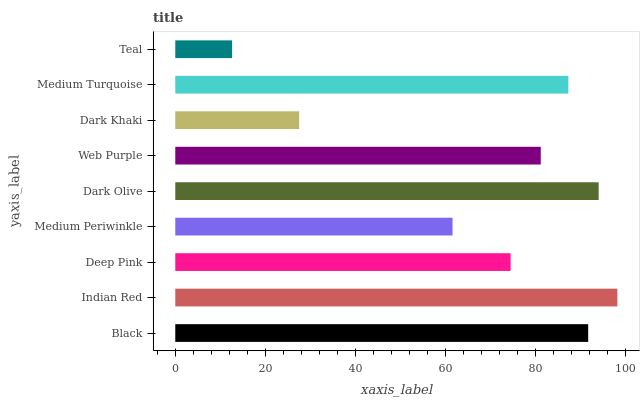Is Teal the minimum?
Answer yes or no. Yes. Is Indian Red the maximum?
Answer yes or no. Yes. Is Deep Pink the minimum?
Answer yes or no. No. Is Deep Pink the maximum?
Answer yes or no. No. Is Indian Red greater than Deep Pink?
Answer yes or no. Yes. Is Deep Pink less than Indian Red?
Answer yes or no. Yes. Is Deep Pink greater than Indian Red?
Answer yes or no. No. Is Indian Red less than Deep Pink?
Answer yes or no. No. Is Web Purple the high median?
Answer yes or no. Yes. Is Web Purple the low median?
Answer yes or no. Yes. Is Medium Periwinkle the high median?
Answer yes or no. No. Is Dark Khaki the low median?
Answer yes or no. No. 